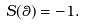Convert formula to latex. <formula><loc_0><loc_0><loc_500><loc_500>S ( \theta ) = - 1 .</formula> 